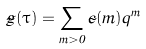Convert formula to latex. <formula><loc_0><loc_0><loc_500><loc_500>\tilde { g } ( \tau ) = \sum _ { m > 0 } \tilde { c } ( m ) q ^ { m }</formula> 